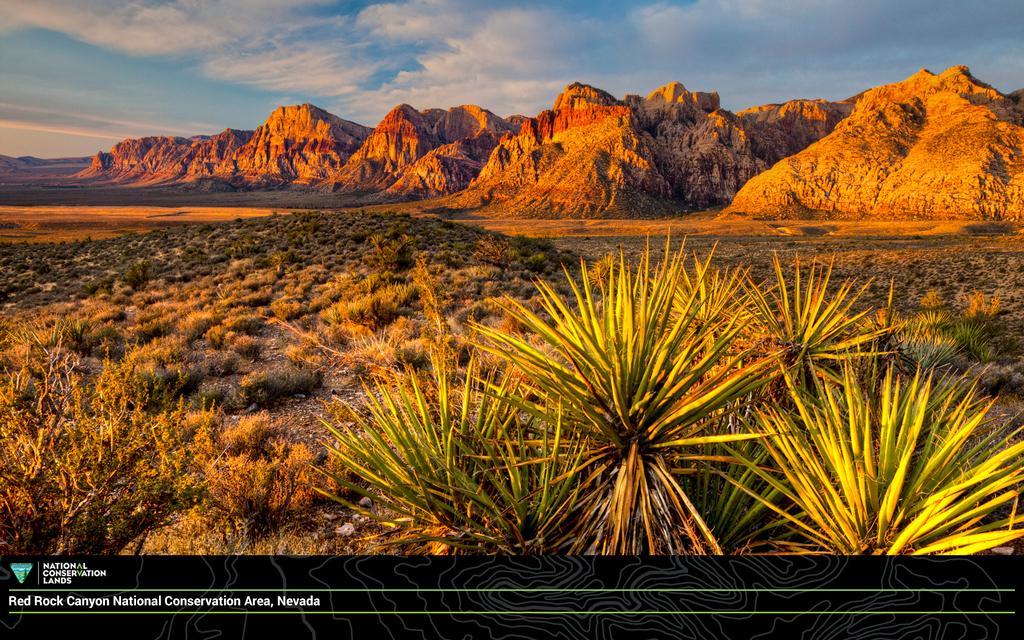Can you describe this image briefly? In this image there are mountains and plants and also grass. At the top there is sky with clouds and at the bottom there is logo with text. 